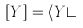Convert formula to latex. <formula><loc_0><loc_0><loc_500><loc_500>[ Y ] = \langle Y \rangle</formula> 